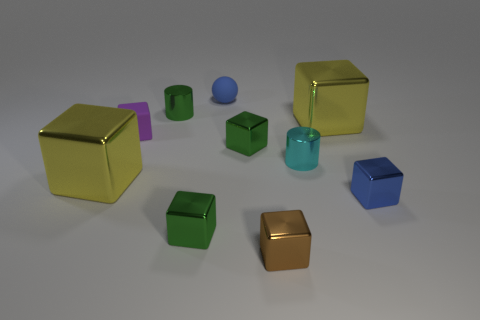There is a blue object that is in front of the shiny cylinder that is behind the matte cube; are there any metal blocks that are to the left of it?
Offer a terse response. Yes. There is a blue object that is the same size as the blue cube; what is its shape?
Offer a terse response. Sphere. There is a green metal cube in front of the blue cube; does it have the same size as the yellow thing that is in front of the tiny cyan metal thing?
Make the answer very short. No. How many cylinders are there?
Your response must be concise. 2. What is the size of the metal cylinder that is left of the cyan metallic object left of the small blue thing on the right side of the blue matte object?
Ensure brevity in your answer.  Small. Is the color of the tiny matte cube the same as the rubber sphere?
Your answer should be compact. No. Are there any other things that have the same size as the ball?
Ensure brevity in your answer.  Yes. There is a brown metallic block; what number of blue matte things are in front of it?
Keep it short and to the point. 0. Are there an equal number of large cubes that are to the right of the tiny blue rubber thing and blue metal objects?
Provide a short and direct response. Yes. What number of objects are either green metallic cylinders or tiny rubber balls?
Your answer should be compact. 2. 